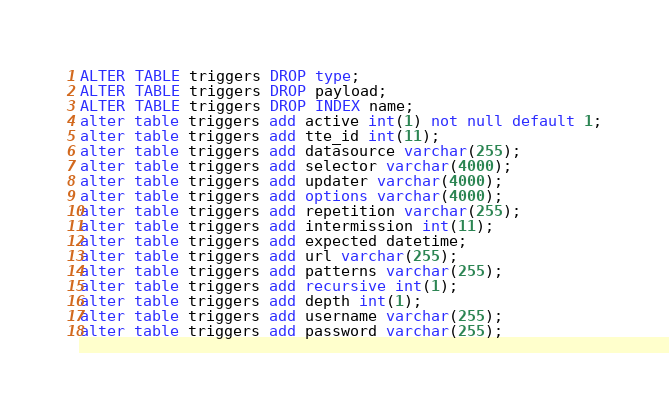<code> <loc_0><loc_0><loc_500><loc_500><_SQL_>ALTER TABLE triggers DROP type;
ALTER TABLE triggers DROP payload;
ALTER TABLE triggers DROP INDEX name;
alter table triggers add active int(1) not null default 1;
alter table triggers add tte_id int(11);
alter table triggers add datasource varchar(255);
alter table triggers add selector varchar(4000);
alter table triggers add updater varchar(4000);
alter table triggers add options varchar(4000);
alter table triggers add repetition varchar(255);
alter table triggers add intermission int(11);
alter table triggers add expected datetime;
alter table triggers add url varchar(255);
alter table triggers add patterns varchar(255);
alter table triggers add recursive int(1);
alter table triggers add depth int(1);
alter table triggers add username varchar(255);
alter table triggers add password varchar(255);</code> 